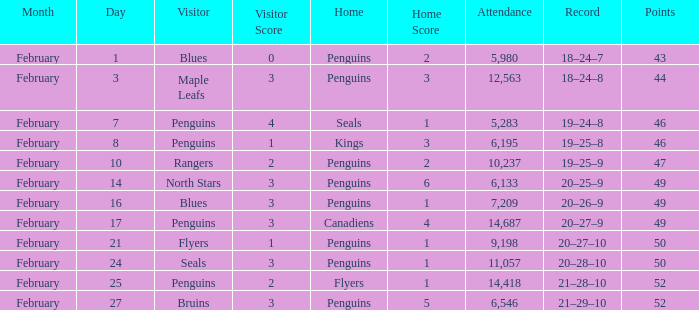Score of 2–1 has what record? 21–28–10. 